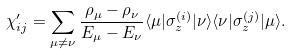Convert formula to latex. <formula><loc_0><loc_0><loc_500><loc_500>\chi _ { i j } ^ { \prime } = \sum _ { \mu \neq \nu } \frac { \rho _ { \mu } - \rho _ { \nu } } { E _ { \mu } - E _ { \nu } } \langle \mu | \sigma _ { z } ^ { ( i ) } | \nu \rangle \langle \nu | \sigma _ { z } ^ { ( j ) } | \mu \rangle .</formula> 